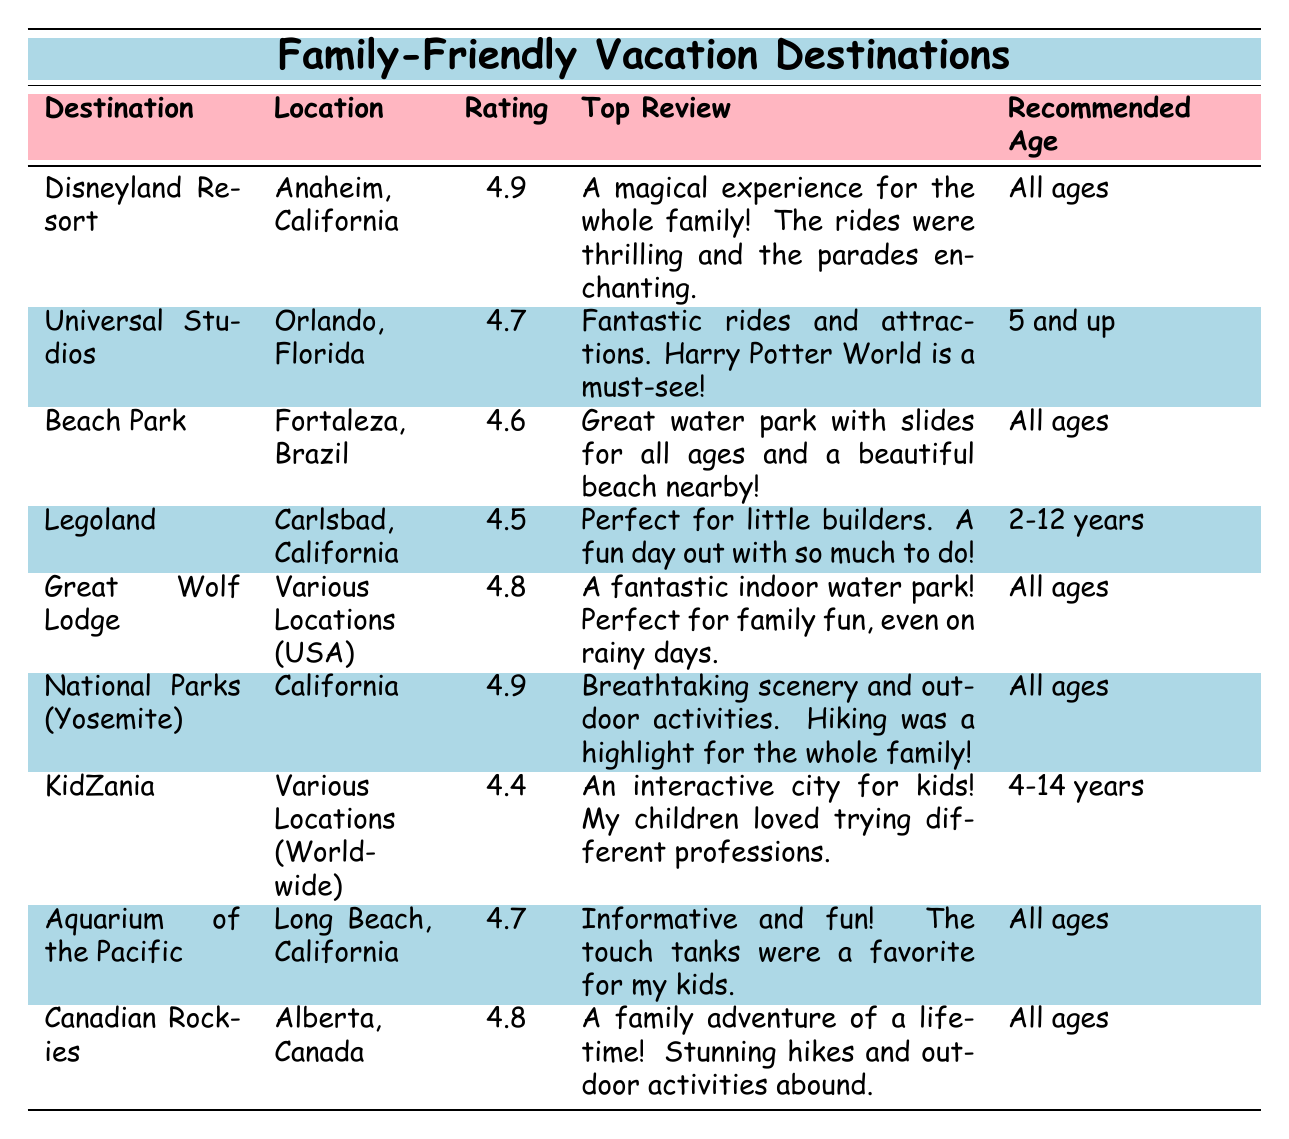What is the average rating of Disneyland Resort? The table indicates that the average rating for Disneyland Resort is listed as 4.9.
Answer: 4.9 Which destination has the lowest average rating? The table shows that KidZania has the lowest average rating at 4.4.
Answer: KidZania Is Beach Park recommended for all ages? The table specifies that Beach Park is recommended for all ages, indicating it is suitable for everyone.
Answer: Yes What activities are available at Universal Studios? From the table, Universal Studios offers activities such as "The Wizarding World of Harry Potter", "Thrilling roller coasters", "Live shows", and "Character meet and greets".
Answer: Several, including Harry Potter World and roller coasters How many destinations are suitable for children ages 4 and up? The destinations suitable for children ages 4 and up are Universal Studios, KidZania, and Legoland. Counting these yields a total of 3.
Answer: 3 Which destination has the highest average rating, and what is it? By examining the table, both Disneyland Resort and National Parks (Yosemite) have the highest average rating of 4.9.
Answer: Disneyland Resort and National Parks (Yosemite) Is Great Wolf Lodge's average rating above 4.5? The table shows Great Wolf Lodge has an average rating of 4.8, which is above 4.5.
Answer: Yes What percentage of the listed destinations are recommended for "All ages"? There are 7 destinations in total, and 5 of them are recommended for all ages. (5/9)*100 = 55.56%, which rounds to approximately 56%.
Answer: 56% If we exclude Legoland, what is the average rating of the remaining destinations? Excluding Legoland's 4.5 rating, we sum up the ratings (4.9 + 4.7 + 4.6 + 4.8 + 4.9 + 4.4 + 4.7 + 4.8 = 37.8) and divide by 8: (37.8 / 8 = 4.725).
Answer: 4.725 Are there any destinations specifically for toddlers aged 2 years? Reviewing the table shows that Legoland is the only destination specifically recommended for children aged 2-12 years.
Answer: Yes, Legoland 